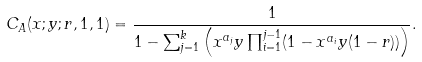<formula> <loc_0><loc_0><loc_500><loc_500>C _ { A } ( x ; y ; r , 1 , 1 ) = \frac { 1 } { 1 - \sum _ { j = 1 } ^ { k } \left ( x ^ { a _ { j } } y \prod _ { i = 1 } ^ { j - 1 } ( 1 - x ^ { a _ { i } } y ( 1 - r ) ) \right ) } .</formula> 